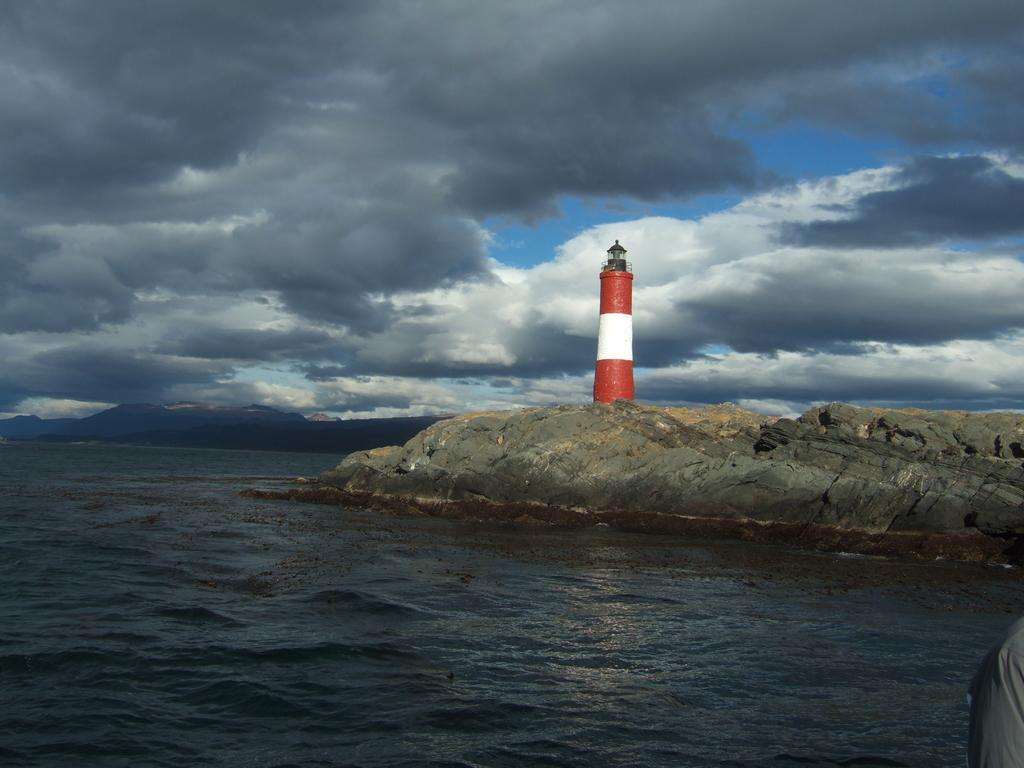What type of natural environment is depicted in the image? The image contains a seashore. What structure can be seen on the rocks near the seashore? There is a lighthouse on the rocks. What is the condition of the sky in the image? The sky is clouded in the image. How many squares can be seen on the lighthouse in the image? There are no squares present on the lighthouse in the image. What type of men are visible near the seashore in the image? There are no men visible in the image. 